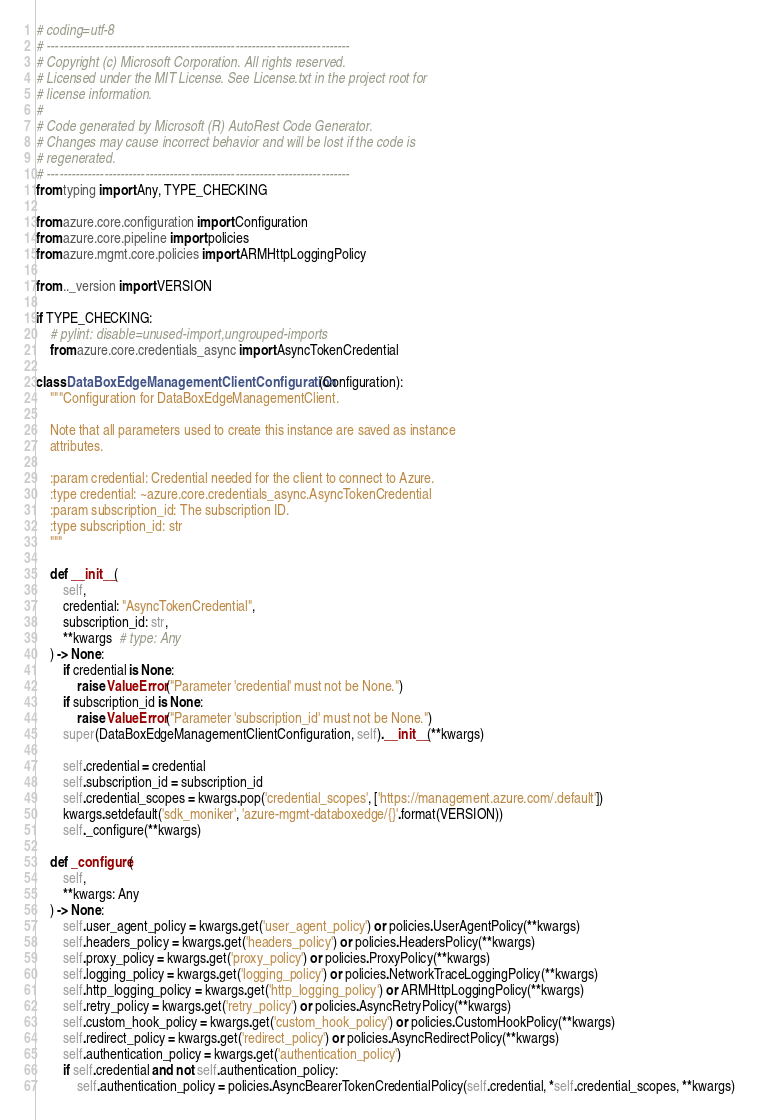Convert code to text. <code><loc_0><loc_0><loc_500><loc_500><_Python_># coding=utf-8
# --------------------------------------------------------------------------
# Copyright (c) Microsoft Corporation. All rights reserved.
# Licensed under the MIT License. See License.txt in the project root for
# license information.
#
# Code generated by Microsoft (R) AutoRest Code Generator.
# Changes may cause incorrect behavior and will be lost if the code is
# regenerated.
# --------------------------------------------------------------------------
from typing import Any, TYPE_CHECKING

from azure.core.configuration import Configuration
from azure.core.pipeline import policies
from azure.mgmt.core.policies import ARMHttpLoggingPolicy

from .._version import VERSION

if TYPE_CHECKING:
    # pylint: disable=unused-import,ungrouped-imports
    from azure.core.credentials_async import AsyncTokenCredential

class DataBoxEdgeManagementClientConfiguration(Configuration):
    """Configuration for DataBoxEdgeManagementClient.

    Note that all parameters used to create this instance are saved as instance
    attributes.

    :param credential: Credential needed for the client to connect to Azure.
    :type credential: ~azure.core.credentials_async.AsyncTokenCredential
    :param subscription_id: The subscription ID.
    :type subscription_id: str
    """

    def __init__(
        self,
        credential: "AsyncTokenCredential",
        subscription_id: str,
        **kwargs  # type: Any
    ) -> None:
        if credential is None:
            raise ValueError("Parameter 'credential' must not be None.")
        if subscription_id is None:
            raise ValueError("Parameter 'subscription_id' must not be None.")
        super(DataBoxEdgeManagementClientConfiguration, self).__init__(**kwargs)

        self.credential = credential
        self.subscription_id = subscription_id
        self.credential_scopes = kwargs.pop('credential_scopes', ['https://management.azure.com/.default'])
        kwargs.setdefault('sdk_moniker', 'azure-mgmt-databoxedge/{}'.format(VERSION))
        self._configure(**kwargs)

    def _configure(
        self,
        **kwargs: Any
    ) -> None:
        self.user_agent_policy = kwargs.get('user_agent_policy') or policies.UserAgentPolicy(**kwargs)
        self.headers_policy = kwargs.get('headers_policy') or policies.HeadersPolicy(**kwargs)
        self.proxy_policy = kwargs.get('proxy_policy') or policies.ProxyPolicy(**kwargs)
        self.logging_policy = kwargs.get('logging_policy') or policies.NetworkTraceLoggingPolicy(**kwargs)
        self.http_logging_policy = kwargs.get('http_logging_policy') or ARMHttpLoggingPolicy(**kwargs)
        self.retry_policy = kwargs.get('retry_policy') or policies.AsyncRetryPolicy(**kwargs)
        self.custom_hook_policy = kwargs.get('custom_hook_policy') or policies.CustomHookPolicy(**kwargs)
        self.redirect_policy = kwargs.get('redirect_policy') or policies.AsyncRedirectPolicy(**kwargs)
        self.authentication_policy = kwargs.get('authentication_policy')
        if self.credential and not self.authentication_policy:
            self.authentication_policy = policies.AsyncBearerTokenCredentialPolicy(self.credential, *self.credential_scopes, **kwargs)
</code> 